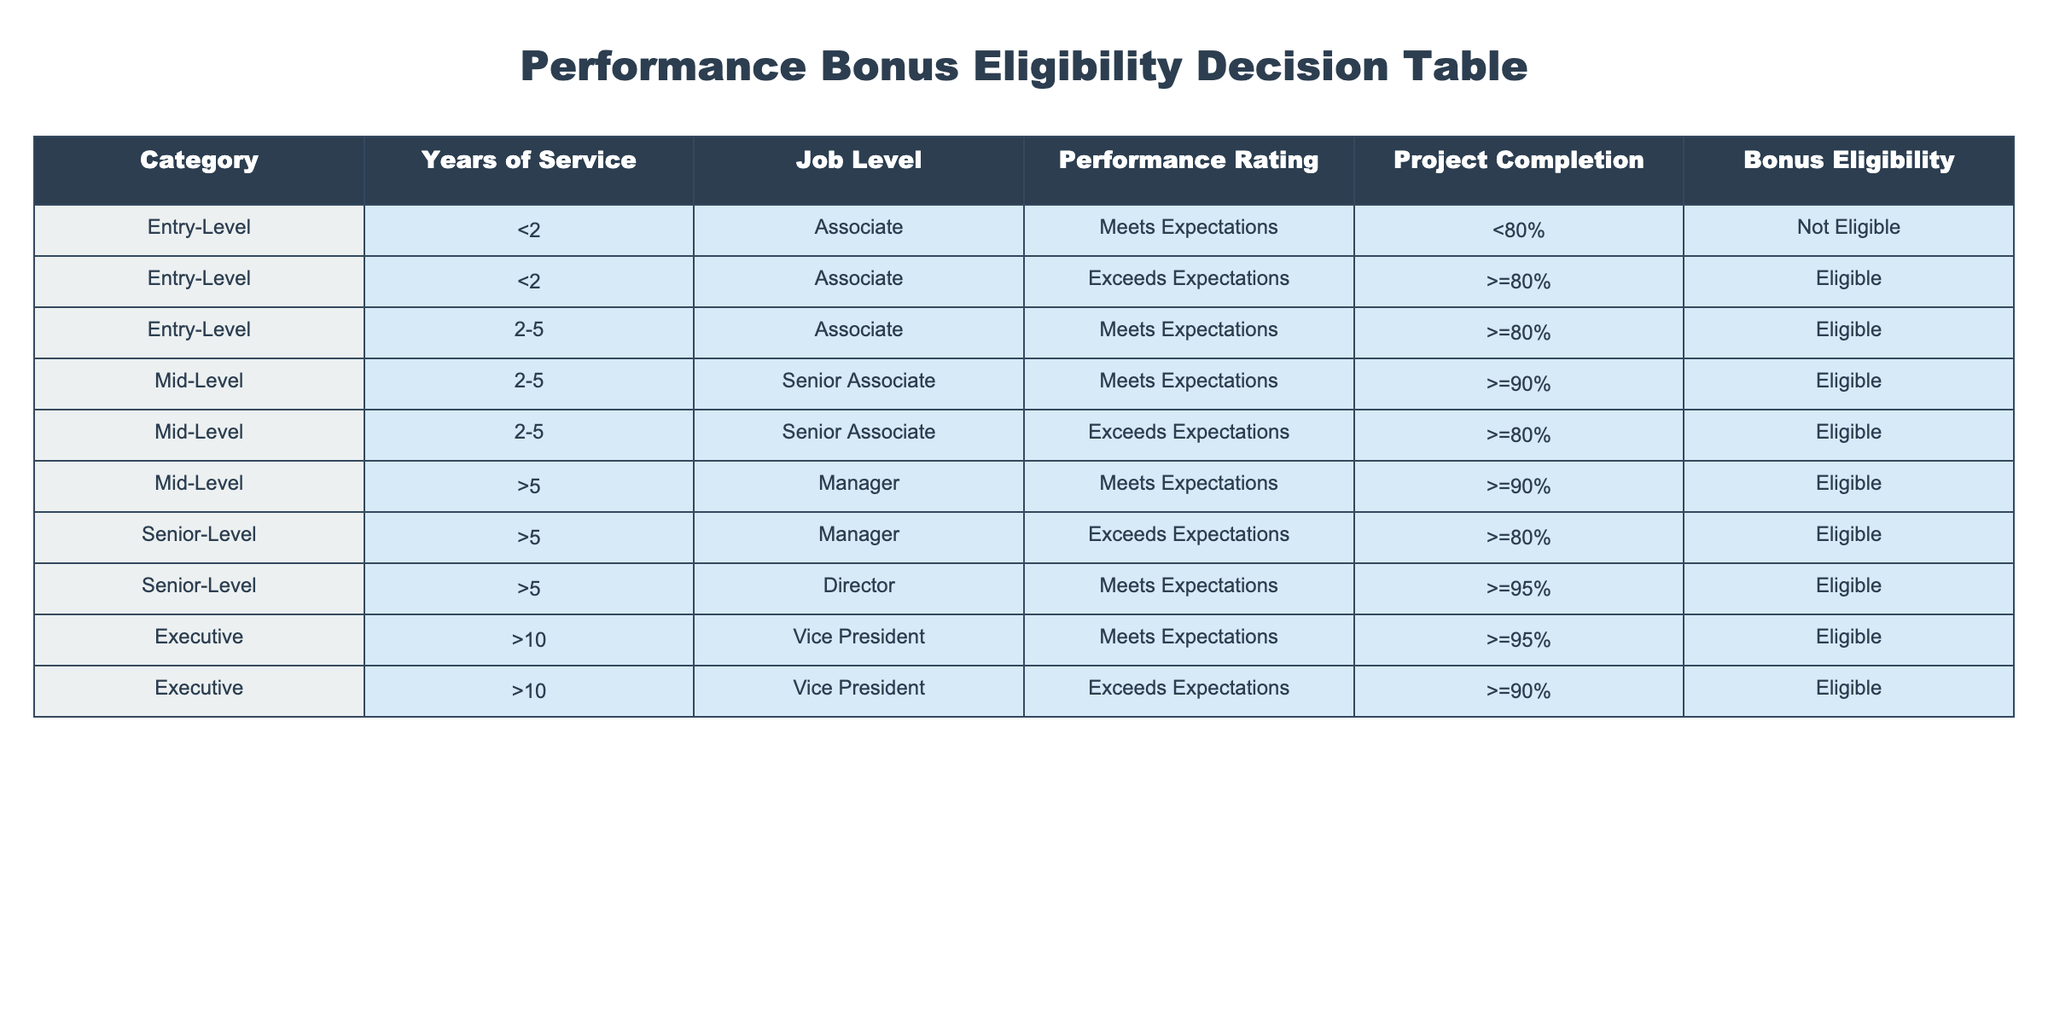What is the eligibility status for a Senior Associate with 4 years of service who meets expectations? A Senior Associate with 4 years of service falls into the "Mid-Level" category with a performance rating of "Meets Expectations." According to the table, for this scenario, they would be eligible for a bonus as long as their project completion rate is at least 90% or they meet the requirement (>90%) for that category. Since they meet expectations, if project completion is below 90%, they are not eligible.
Answer: Not Eligible Is an Entry-Level employee who exceeds expectations eligible for a bonus? Yes, an Entry-Level employee in the "Associate" job level who exceeds expectations and has 80% or more project completion is listed as eligible according to the table.
Answer: Yes How many categories have eligibility requirements based on project completion rates? To find this, we need to count the unique categories where project completion rates influence eligibility. The table shows that multiple categories have varying requirements: Entry-Level (<2 years, >=80%), Mid-Level (2-5 years, >=90%) and Senior-Level (>5 years, >=95%). Specifically, there are three categories that require project completion rates for eligibility.
Answer: 3 Is it possible for a Manager with more than 5 years of service to be not eligible for a bonus if they meet expectations? No, a Manager with more than 5 years of service and a performance rating of "Meets Expectations" would be eligible for a bonus as long as their project completion is at least 90%. The table confirms that both conditions lead to bonus eligibility.
Answer: No If a Vice President has worked for 11 years and exceeds expectations with a project completion of 89%, what is their bonus eligibility? For the Vice President category (Executive), the eligibility varies based on performance rating and project completion. The table shows they need at least 90% project completion when exceeding expectations. Since the Vice President has only 89% project completion while exceeding expectations, they do not meet the requirement, making them not eligible.
Answer: Not Eligible 